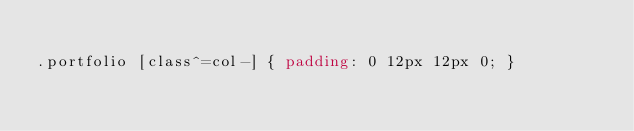<code> <loc_0><loc_0><loc_500><loc_500><_CSS_>
.portfolio [class^=col-] { padding: 0 12px 12px 0; }




</code> 